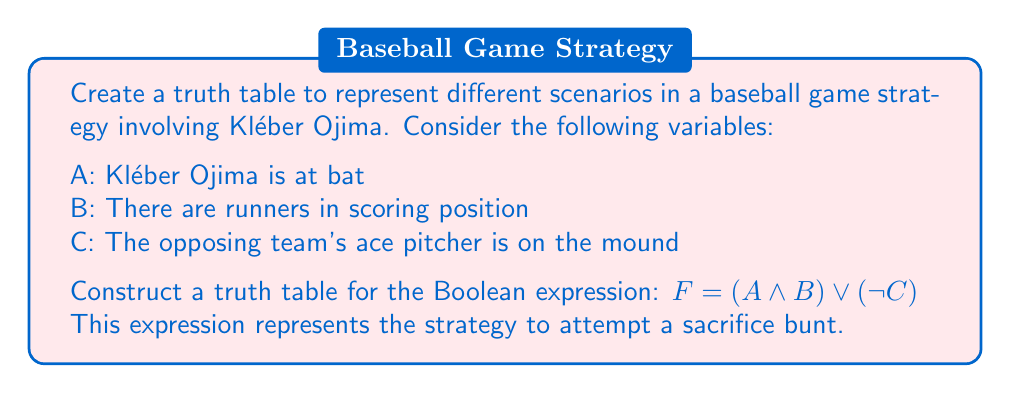Solve this math problem. To create a truth table for the given Boolean expression, we'll follow these steps:

1. Identify the variables: A, B, and C
2. List all possible combinations of these variables (2^3 = 8 combinations)
3. Evaluate the sub-expressions: $(A \land B)$ and $(\neg C)$
4. Evaluate the final expression: $F = (A \land B) \lor (\neg C)$

Here's the step-by-step construction of the truth table:

1. Create columns for A, B, and C:
   $$
   \begin{array}{|c|c|c|}
   \hline
   A & B & C \\
   \hline
   0 & 0 & 0 \\
   0 & 0 & 1 \\
   0 & 1 & 0 \\
   0 & 1 & 1 \\
   1 & 0 & 0 \\
   1 & 0 & 1 \\
   1 & 1 & 0 \\
   1 & 1 & 1 \\
   \hline
   \end{array}
   $$

2. Add a column for $(A \land B)$:
   $$
   \begin{array}{|c|c|c|c|}
   \hline
   A & B & C & (A \land B) \\
   \hline
   0 & 0 & 0 & 0 \\
   0 & 0 & 1 & 0 \\
   0 & 1 & 0 & 0 \\
   0 & 1 & 1 & 0 \\
   1 & 0 & 0 & 0 \\
   1 & 0 & 1 & 0 \\
   1 & 1 & 0 & 1 \\
   1 & 1 & 1 & 1 \\
   \hline
   \end{array}
   $$

3. Add a column for $(\neg C)$:
   $$
   \begin{array}{|c|c|c|c|c|}
   \hline
   A & B & C & (A \land B) & (\neg C) \\
   \hline
   0 & 0 & 0 & 0 & 1 \\
   0 & 0 & 1 & 0 & 0 \\
   0 & 1 & 0 & 0 & 1 \\
   0 & 1 & 1 & 0 & 0 \\
   1 & 0 & 0 & 0 & 1 \\
   1 & 0 & 1 & 0 & 0 \\
   1 & 1 & 0 & 1 & 1 \\
   1 & 1 & 1 & 1 & 0 \\
   \hline
   \end{array}
   $$

4. Add the final column for $F = (A \land B) \lor (\neg C)$:
   $$
   \begin{array}{|c|c|c|c|c|c|}
   \hline
   A & B & C & (A \land B) & (\neg C) & F \\
   \hline
   0 & 0 & 0 & 0 & 1 & 1 \\
   0 & 0 & 1 & 0 & 0 & 0 \\
   0 & 1 & 0 & 0 & 1 & 1 \\
   0 & 1 & 1 & 0 & 0 & 0 \\
   1 & 0 & 0 & 0 & 1 & 1 \\
   1 & 0 & 1 & 0 & 0 & 0 \\
   1 & 1 & 0 & 1 & 1 & 1 \\
   1 & 1 & 1 & 1 & 0 & 1 \\
   \hline
   \end{array}
   $$

This completes the truth table for the given Boolean expression.
Answer: $$
\begin{array}{|c|c|c|c|}
\hline
A & B & C & F \\
\hline
0 & 0 & 0 & 1 \\
0 & 0 & 1 & 0 \\
0 & 1 & 0 & 1 \\
0 & 1 & 1 & 0 \\
1 & 0 & 0 & 1 \\
1 & 0 & 1 & 0 \\
1 & 1 & 0 & 1 \\
1 & 1 & 1 & 1 \\
\hline
\end{array}
$$ 